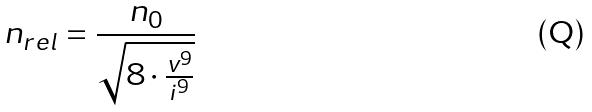<formula> <loc_0><loc_0><loc_500><loc_500>n _ { r e l } = \frac { n _ { 0 } } { \sqrt { 8 \cdot \frac { v ^ { 9 } } { i ^ { 9 } } } }</formula> 